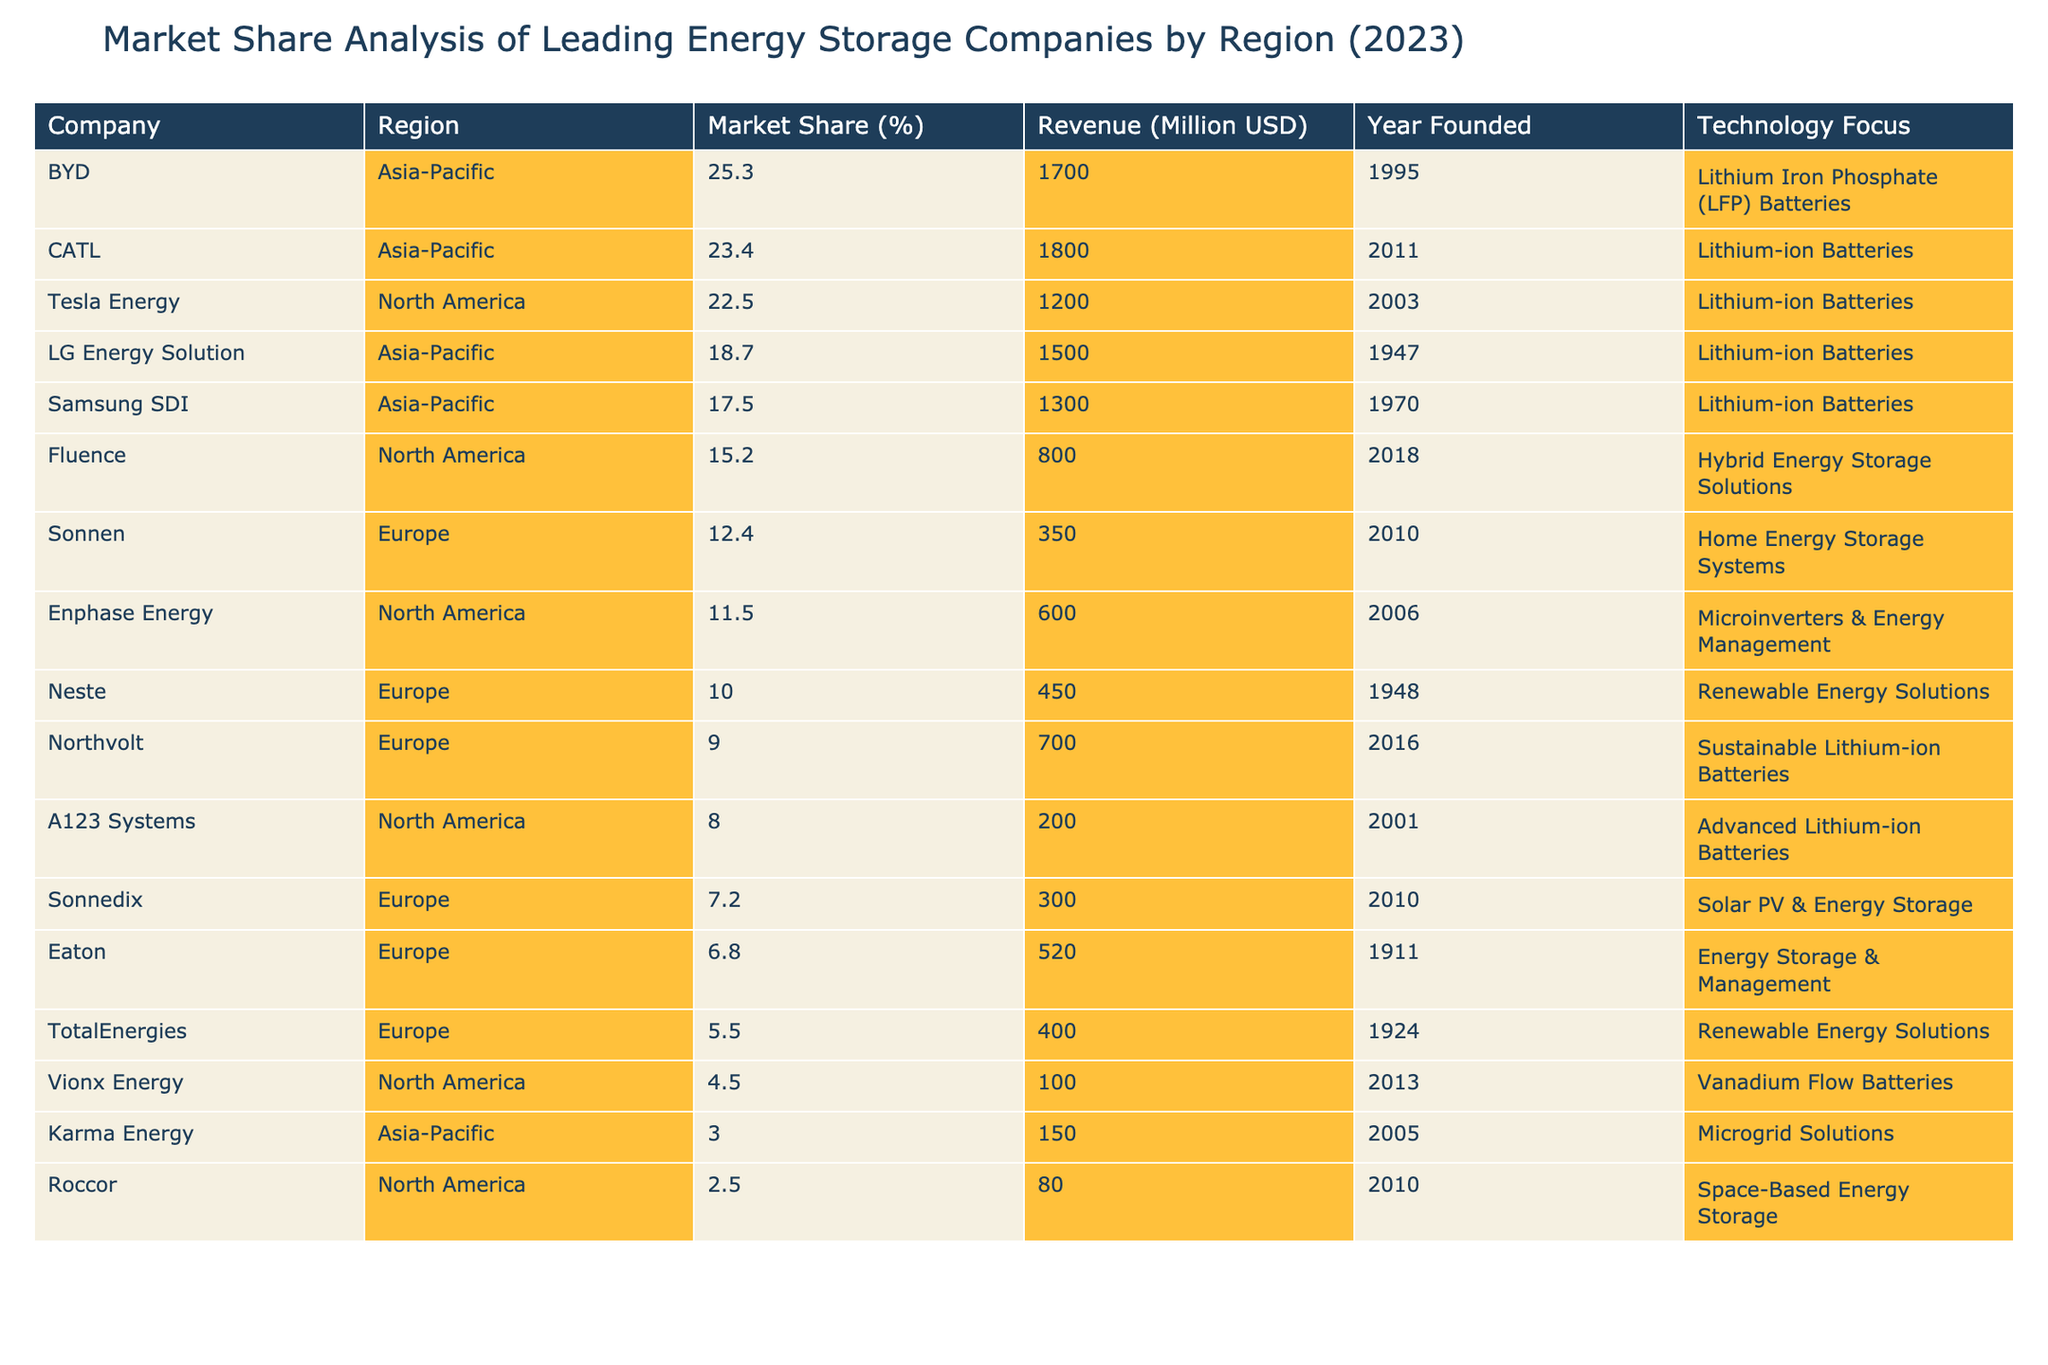What is the market share of BYD in the Asia-Pacific region? Referring to the table, BYD's market share in the Asia-Pacific region is listed as 25.3%.
Answer: 25.3% Which company has the highest market share in North America? The table shows that Tesla Energy has the highest market share in North America at 22.5%.
Answer: Tesla Energy What is the total market share of the top three companies in the Asia-Pacific region? Adding the market shares of BYD (25.3%), LG Energy Solution (18.7%), and CATL (23.4%) gives a total of 67.4%.
Answer: 67.4% Is LG Energy Solution's revenue higher than that of Neste? According to the table, LG Energy Solution's revenue is 1500 million USD, which is higher than Neste's revenue of 450 million USD.
Answer: Yes What is the average market share of all companies listed in Europe? The market shares for European companies are 10.0%, 12.4%, 5.5%, 6.8%, 7.2%, and 9.0%. Calculating the average gives (10.0 + 12.4 + 5.5 + 6.8 + 7.2 + 9.0) / 6 = 8.68%.
Answer: 8.68% Which technology focus is most common among the companies with the highest market shares? Upon reviewing the table, lithium-ion batteries are the technology focus for four out of the five companies with the highest market shares.
Answer: Lithium-ion batteries By what percentage does Tesla Energy's market share exceed that of Vionx Energy? Tesla Energy has a market share of 22.5% and Vionx Energy has 4.5%. The difference is 22.5% - 4.5% = 18%.
Answer: 18% Which company has the earliest founding year among the listed firms? The table shows that LG Energy Solution was founded in 1947, which is the earliest year compared to other companies.
Answer: LG Energy Solution What is the total combined revenue of all companies in the table? Summing the revenues: 1200 + 1500 + 1700 + 800 + 1300 + 450 + 350 + 600 + 1800 + 100 + 200 + 400 + 520 + 300 + 150 + 80 + 700 = 10100 million USD.
Answer: 10100 million USD Which company focuses on microgrid solutions, and what is its revenue? Karma Energy focuses on microgrid solutions, and its listed revenue is 150 million USD.
Answer: Karma Energy, 150 million USD 